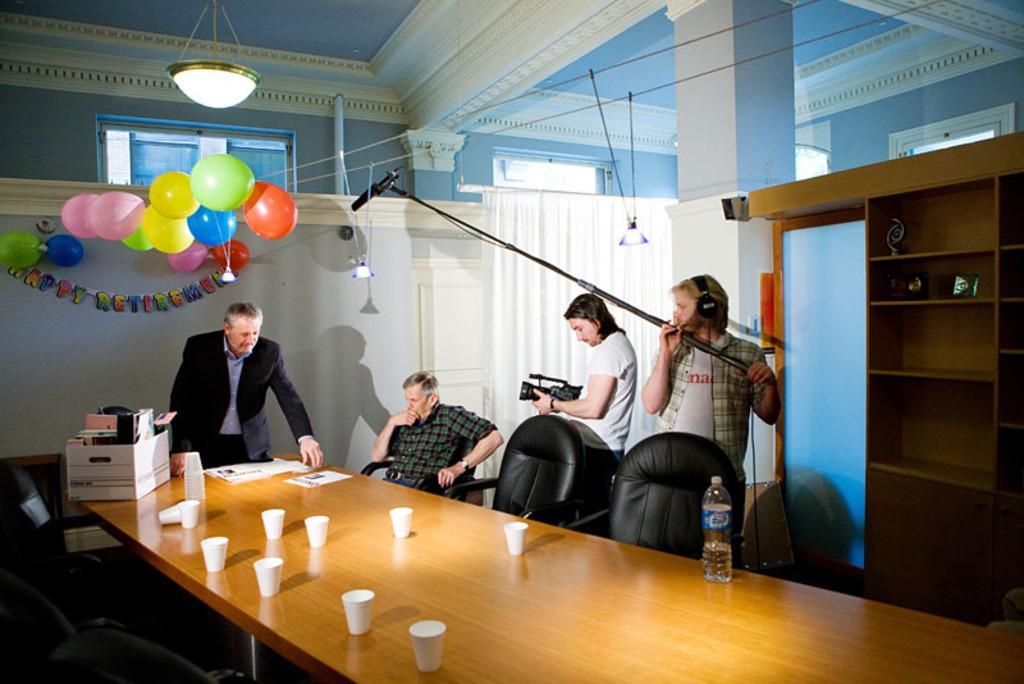Describe this image in one or two sentences. As we can see in the image there is a wall, balloons, light, mic and few people over here and there is a table. On table there are glasses, paper and box. 